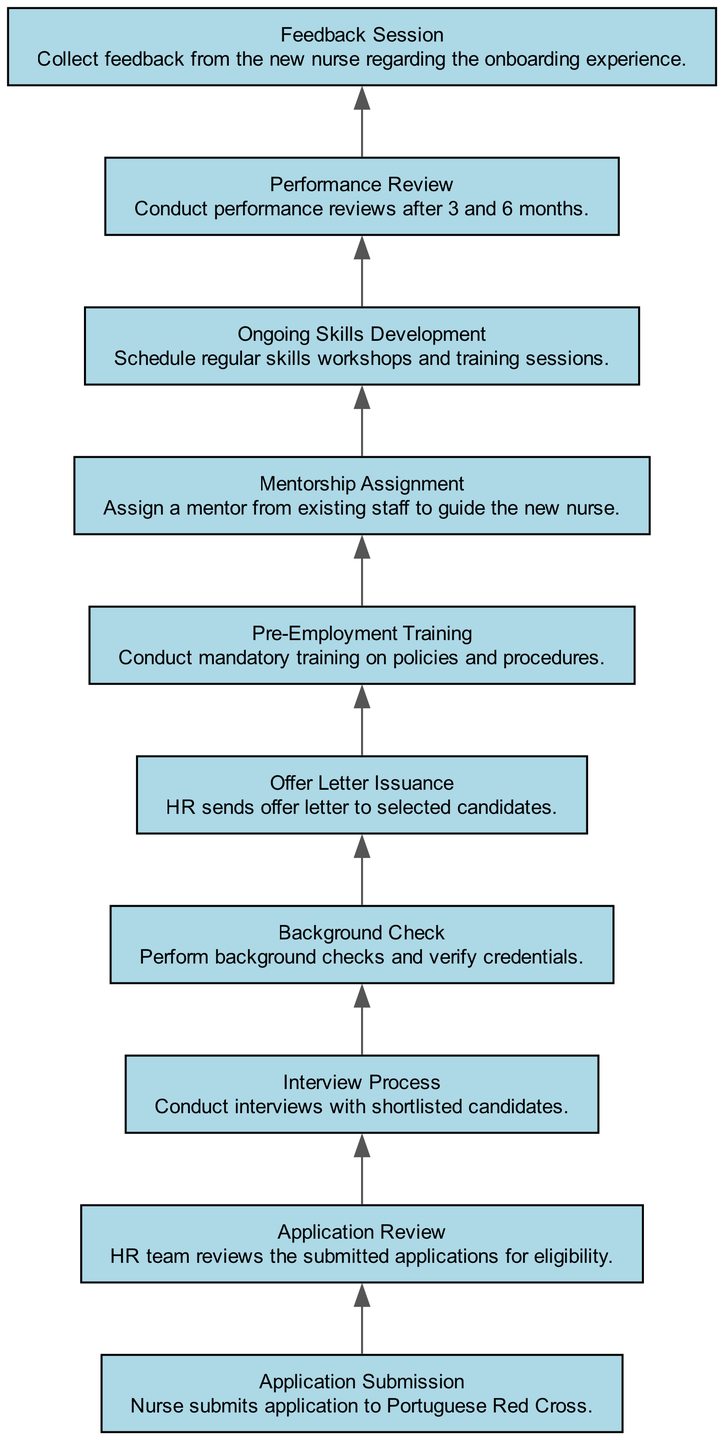What is the first step in the onboarding process? The first step is "Application Submission," where the nurse submits an application to the Portuguese Red Cross.
Answer: Application Submission How many total steps are in the onboarding process? There are 10 steps, as indicated by the 10 unique nodes in the diagram that represent the different stages of the process.
Answer: 10 What step comes after "Background Check"? The step that comes after "Background Check" is "Offer Letter Issuance," which signifies the next action taken after completing the background checks.
Answer: Offer Letter Issuance Which step involves feedback collection? "Feedback Session" is the step that involves collecting feedback from the new nurse regarding their onboarding experience, as described in the diagram.
Answer: Feedback Session What is the relationship between "Pre-Employment Training" and "Mentorship Assignment"? "Pre-Employment Training" comes before "Mentorship Assignment." This indicates that training is completed prior to assigning a mentor to the new nurse.
Answer: Pre-Employment Training before Mentorship Assignment What is the purpose of the "Performance Review"? The purpose of the "Performance Review" is to conduct evaluations of the new nurse's performance after a set period of 3 and 6 months, assessing their integration and skills.
Answer: Evaluate performance How many unique onboarding activities have a training focus? There are three activities focused on training: "Pre-Employment Training," "Ongoing Skills Development," and "Mentorship Assignment" that involve training aspects for new staff.
Answer: 3 What type of flow does this diagram represent? The diagram represents a "Bottom Up Flow Chart," indicating that it visualizes a process that starts from the initial stage at the bottom and progresses upward through subsequent steps.
Answer: Bottom Up Flow Chart What action is represented in node 6? Node 6 represents "Pre-Employment Training," which involves conducting mandatory training on policies and procedures for new hires before they officially start their roles.
Answer: Pre-Employment Training 